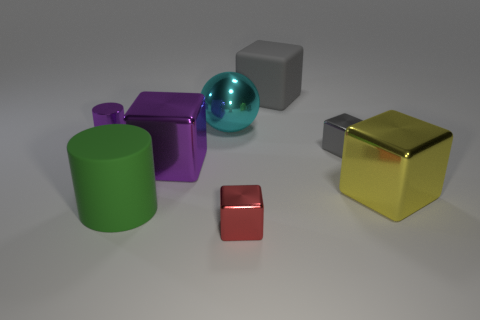There is a gray matte object; what shape is it? cube 